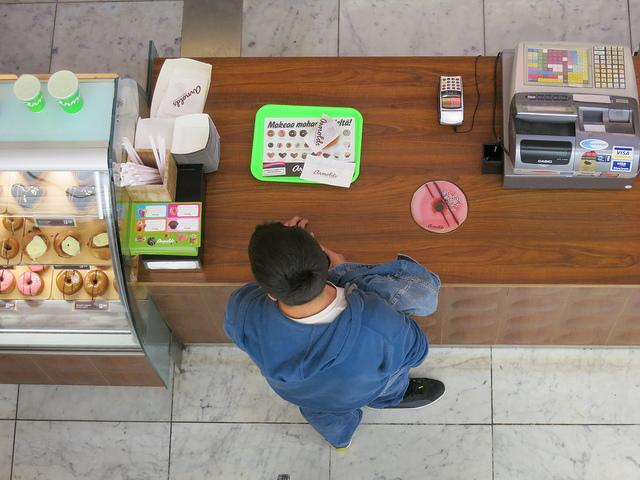Who is the man waiting for?

Choices:
A) mechanic
B) cashier
C) doctor
D) banker cashier 